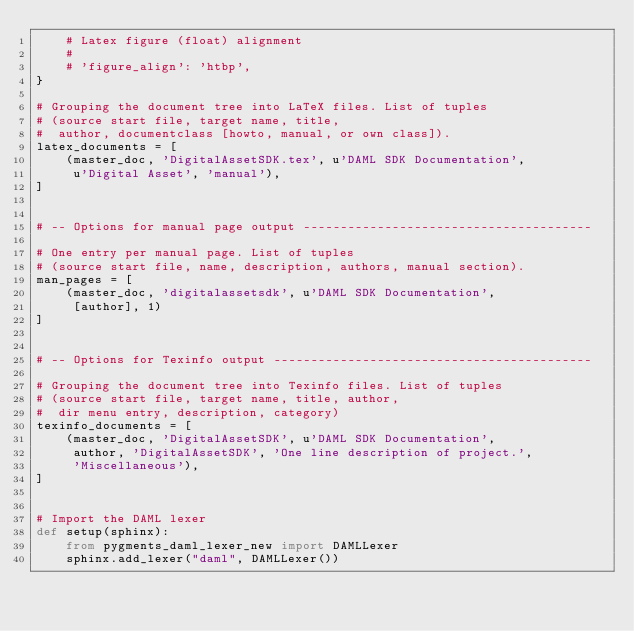<code> <loc_0><loc_0><loc_500><loc_500><_Python_>    # Latex figure (float) alignment
    #
    # 'figure_align': 'htbp',
}

# Grouping the document tree into LaTeX files. List of tuples
# (source start file, target name, title,
#  author, documentclass [howto, manual, or own class]).
latex_documents = [
    (master_doc, 'DigitalAssetSDK.tex', u'DAML SDK Documentation',
     u'Digital Asset', 'manual'),
]


# -- Options for manual page output ---------------------------------------

# One entry per manual page. List of tuples
# (source start file, name, description, authors, manual section).
man_pages = [
    (master_doc, 'digitalassetsdk', u'DAML SDK Documentation',
     [author], 1)
]


# -- Options for Texinfo output -------------------------------------------

# Grouping the document tree into Texinfo files. List of tuples
# (source start file, target name, title, author,
#  dir menu entry, description, category)
texinfo_documents = [
    (master_doc, 'DigitalAssetSDK', u'DAML SDK Documentation',
     author, 'DigitalAssetSDK', 'One line description of project.',
     'Miscellaneous'),
]


# Import the DAML lexer
def setup(sphinx):
    from pygments_daml_lexer_new import DAMLLexer
    sphinx.add_lexer("daml", DAMLLexer())
</code> 